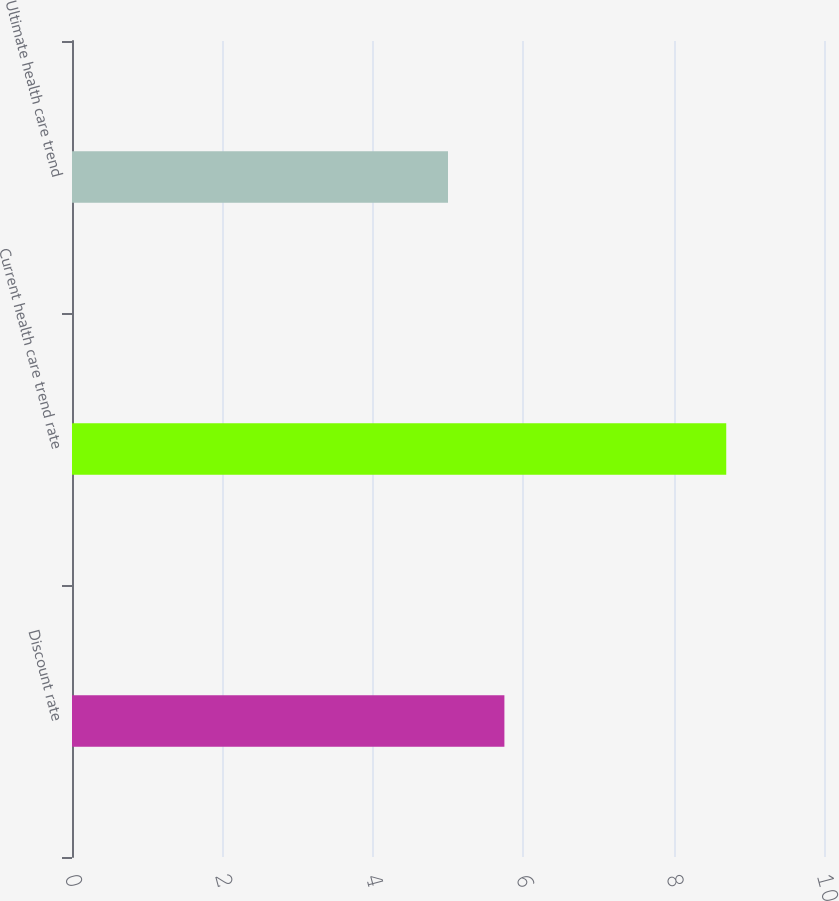Convert chart. <chart><loc_0><loc_0><loc_500><loc_500><bar_chart><fcel>Discount rate<fcel>Current health care trend rate<fcel>Ultimate health care trend<nl><fcel>5.75<fcel>8.7<fcel>5<nl></chart> 